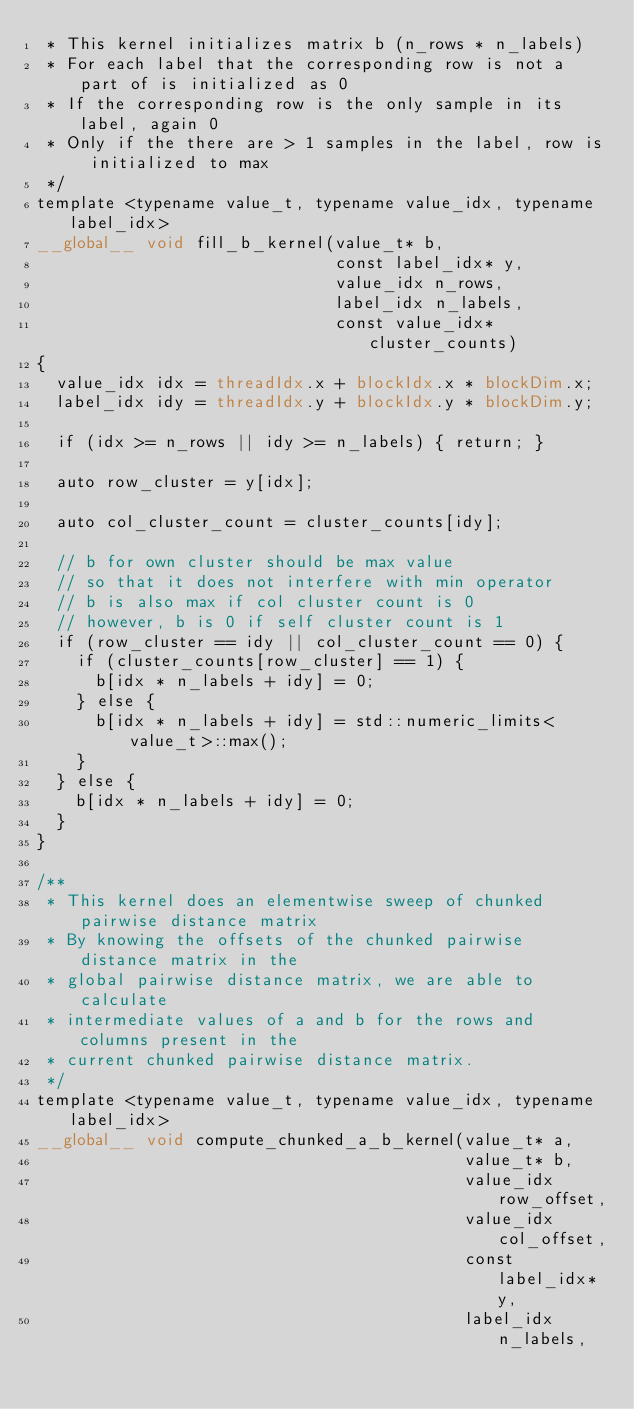<code> <loc_0><loc_0><loc_500><loc_500><_Cuda_> * This kernel initializes matrix b (n_rows * n_labels)
 * For each label that the corresponding row is not a part of is initialized as 0
 * If the corresponding row is the only sample in its label, again 0
 * Only if the there are > 1 samples in the label, row is initialized to max
 */
template <typename value_t, typename value_idx, typename label_idx>
__global__ void fill_b_kernel(value_t* b,
                              const label_idx* y,
                              value_idx n_rows,
                              label_idx n_labels,
                              const value_idx* cluster_counts)
{
  value_idx idx = threadIdx.x + blockIdx.x * blockDim.x;
  label_idx idy = threadIdx.y + blockIdx.y * blockDim.y;

  if (idx >= n_rows || idy >= n_labels) { return; }

  auto row_cluster = y[idx];

  auto col_cluster_count = cluster_counts[idy];

  // b for own cluster should be max value
  // so that it does not interfere with min operator
  // b is also max if col cluster count is 0
  // however, b is 0 if self cluster count is 1
  if (row_cluster == idy || col_cluster_count == 0) {
    if (cluster_counts[row_cluster] == 1) {
      b[idx * n_labels + idy] = 0;
    } else {
      b[idx * n_labels + idy] = std::numeric_limits<value_t>::max();
    }
  } else {
    b[idx * n_labels + idy] = 0;
  }
}

/**
 * This kernel does an elementwise sweep of chunked pairwise distance matrix
 * By knowing the offsets of the chunked pairwise distance matrix in the
 * global pairwise distance matrix, we are able to calculate
 * intermediate values of a and b for the rows and columns present in the
 * current chunked pairwise distance matrix.
 */
template <typename value_t, typename value_idx, typename label_idx>
__global__ void compute_chunked_a_b_kernel(value_t* a,
                                           value_t* b,
                                           value_idx row_offset,
                                           value_idx col_offset,
                                           const label_idx* y,
                                           label_idx n_labels,</code> 